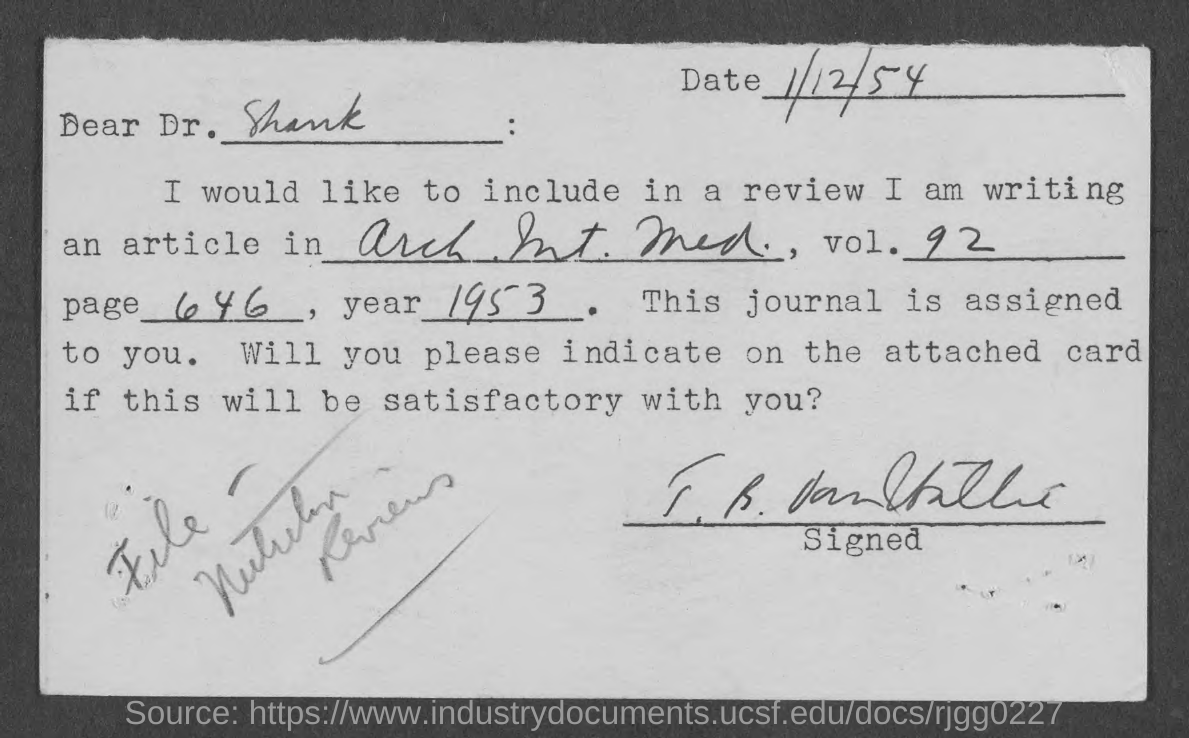To whom is this letter addressed to?
Offer a terse response. Dr. shank. Mention the "Date" given at  right top corner of the letter?
Offer a very short reply. 1/12/54. Provide the "vol." number mentioned?
Provide a succinct answer. 92. Provide the "page" number mentioned in the letter?
Offer a terse response. 646. Article is written in which "year"?
Your response must be concise. 1953. 